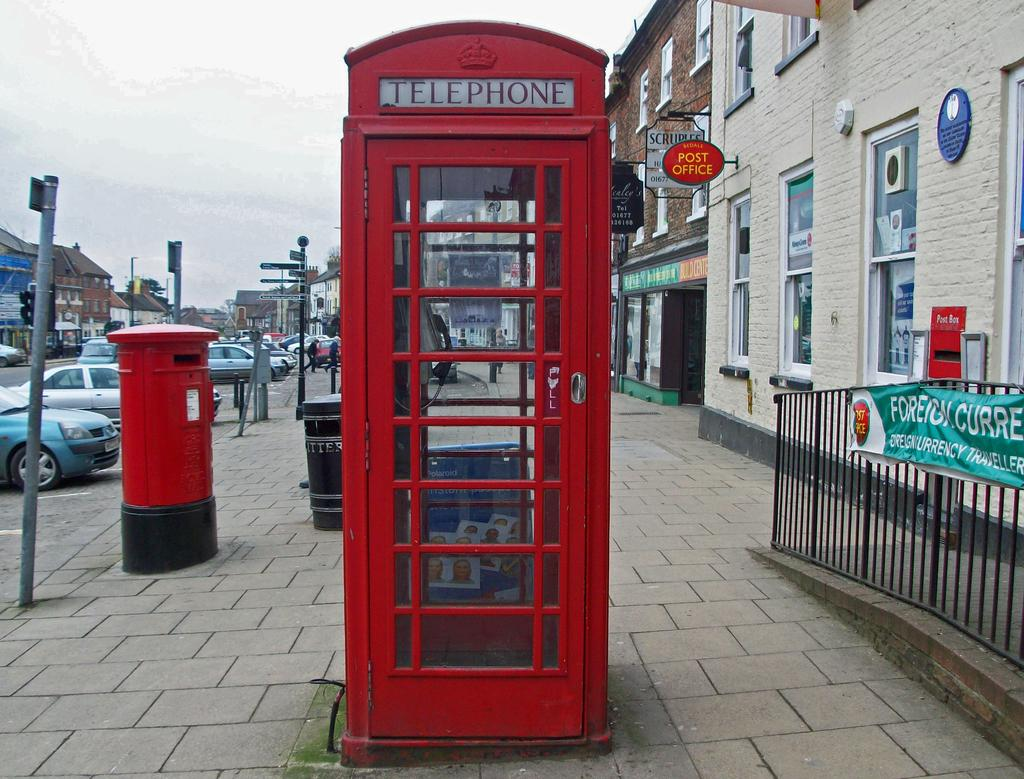<image>
Write a terse but informative summary of the picture. A large red phone booth like the one from Doctor Who that says Telephone. 